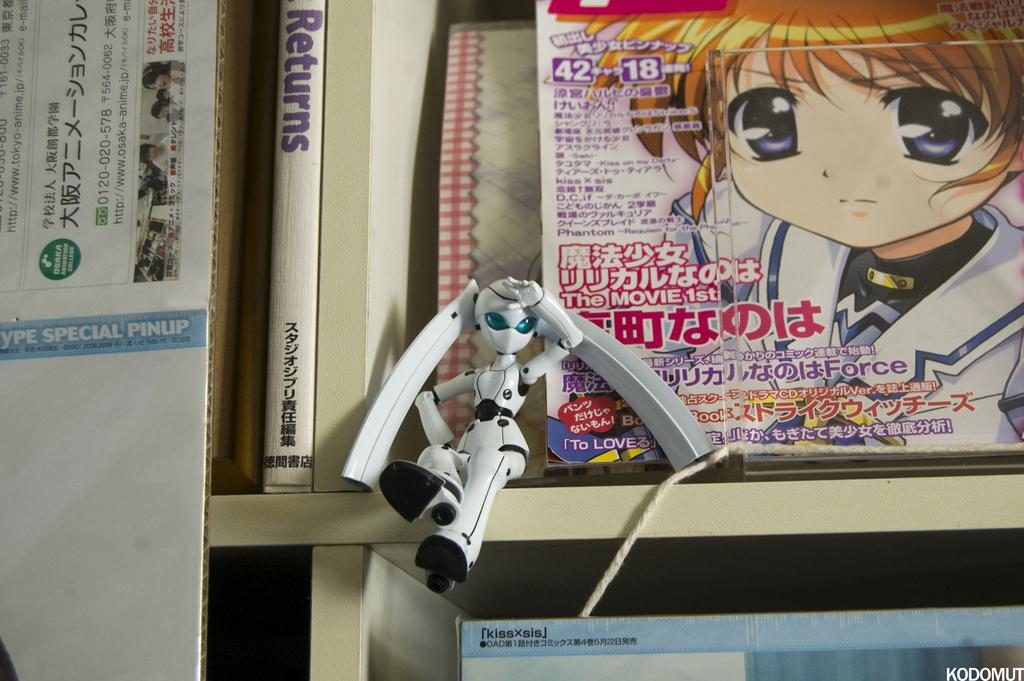What is the main subject in the foreground of the picture? There is a toy robot in the foreground of the picture. Where is the toy robot positioned? The toy robot is sitting at the edge of a shelf. What can be seen in the background of the image? There is a shelf with books in the background of the image. How many clams are visible on the shelf with books in the image? There are no clams visible on the shelf with books in the image. What type of brick is used to construct the toy robot? The toy robot is not made of bricks; it is a toy robot. 